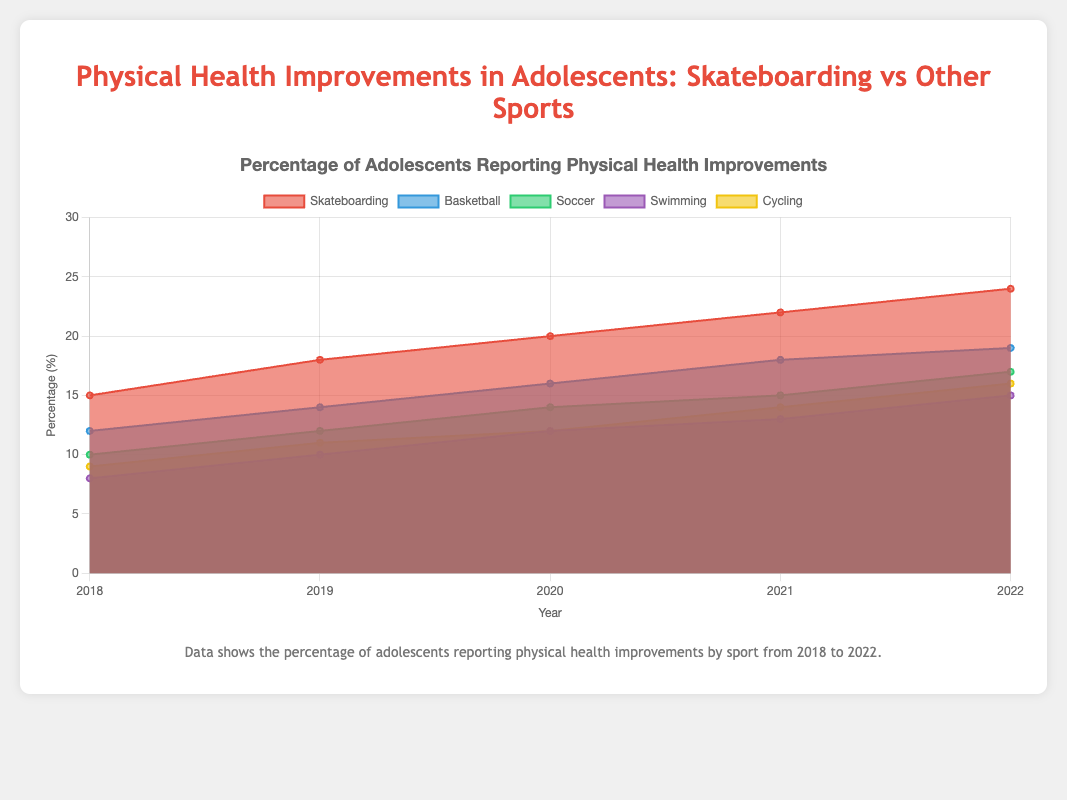What's the title of the chart? The title of the chart is prominently displayed at the top and reads "Percentage of Adolescents Reporting Physical Health Improvements".
Answer: Percentage of Adolescents Reporting Physical Health Improvements What is the y-axis measuring? The y-axis of the chart measures the "Percentage (%)" of adolescents reporting physical health improvements.
Answer: Percentage (%) Which sport saw the highest physical health improvements in 2022? By observing the data points for the year 2022, we can see that the line representing Skateboarding reaches the highest point on the y-axis for that year.
Answer: Skateboarding How did the physical health improvements in Cycling change from 2018 to 2022? The data for Cycling shows that it increased from 9% in 2018 to 16% in 2022. This can be seen by tracking the line from 2018 to 2022.
Answer: Increased from 9% to 16% In which year did Skateboarding experience the largest increase in physical health improvements? By comparing year-over-year increases, Skateboarding saw its largest increase from 2018 to 2019 (3 percentage points increase).
Answer: 2018 to 2019 Which two sports had the smallest difference in physical health improvements in 2020? By examining the data points for 2020, we see that Soccer and Cycling both had 14% improvements, leading to a difference of 0%.
Answer: Soccer and Cycling On average, how much did the physical health improvements in Swimming increase per year? Calculate the total increase over the years (from 8% in 2018 to 15% in 2022 is a 7% increase) and divide by the number of years (5 years), resulting in an average yearly increase of 1.4%.
Answer: 1.4% Which sport showed a consistent increase in physical health improvements every year? By following the lines across the years for each sport, only the line for Skateboarding consistently increases each year.
Answer: Skateboarding In 2021, did Basketball or Soccer have higher reported physical health improvements? The chart shows that in 2021, Basketball was at 18% and Soccer was at 15%, making Basketball higher.
Answer: Basketball 